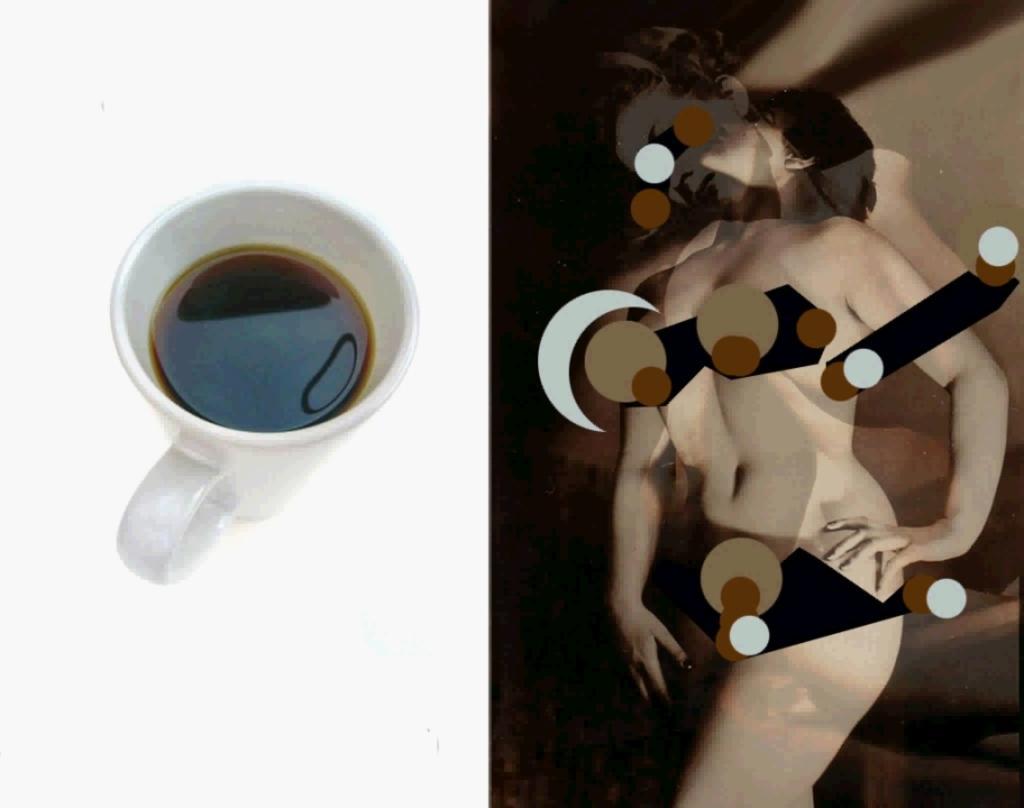In one or two sentences, can you explain what this image depicts? In this picture I can see collage of couple of images, in the first picture I can see a cup of tea and in the second picture I can see a woman and few graphical images and looks like a wall in the background. 